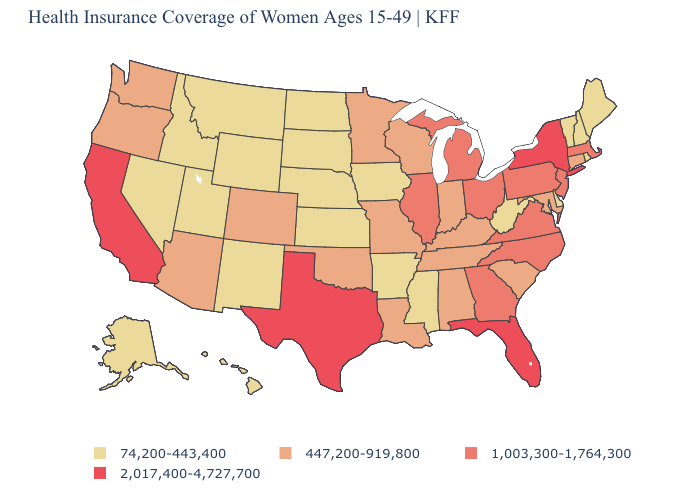What is the highest value in states that border Michigan?
Answer briefly. 1,003,300-1,764,300. Does the first symbol in the legend represent the smallest category?
Answer briefly. Yes. Is the legend a continuous bar?
Write a very short answer. No. Which states have the lowest value in the Northeast?
Answer briefly. Maine, New Hampshire, Rhode Island, Vermont. How many symbols are there in the legend?
Be succinct. 4. What is the value of California?
Concise answer only. 2,017,400-4,727,700. What is the value of Kentucky?
Be succinct. 447,200-919,800. What is the highest value in states that border Oklahoma?
Write a very short answer. 2,017,400-4,727,700. Does New Jersey have the lowest value in the USA?
Short answer required. No. Does Rhode Island have the highest value in the USA?
Concise answer only. No. Among the states that border Mississippi , which have the lowest value?
Answer briefly. Arkansas. Which states have the lowest value in the USA?
Keep it brief. Alaska, Arkansas, Delaware, Hawaii, Idaho, Iowa, Kansas, Maine, Mississippi, Montana, Nebraska, Nevada, New Hampshire, New Mexico, North Dakota, Rhode Island, South Dakota, Utah, Vermont, West Virginia, Wyoming. Name the states that have a value in the range 447,200-919,800?
Write a very short answer. Alabama, Arizona, Colorado, Connecticut, Indiana, Kentucky, Louisiana, Maryland, Minnesota, Missouri, Oklahoma, Oregon, South Carolina, Tennessee, Washington, Wisconsin. Name the states that have a value in the range 447,200-919,800?
Quick response, please. Alabama, Arizona, Colorado, Connecticut, Indiana, Kentucky, Louisiana, Maryland, Minnesota, Missouri, Oklahoma, Oregon, South Carolina, Tennessee, Washington, Wisconsin. What is the value of Vermont?
Concise answer only. 74,200-443,400. 